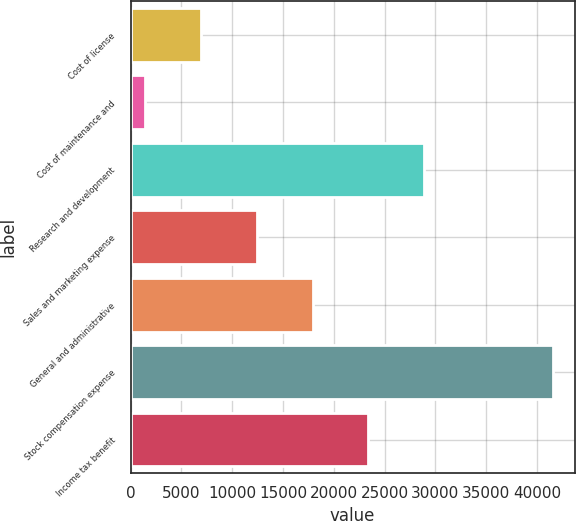<chart> <loc_0><loc_0><loc_500><loc_500><bar_chart><fcel>Cost of license<fcel>Cost of maintenance and<fcel>Research and development<fcel>Sales and marketing expense<fcel>General and administrative<fcel>Stock compensation expense<fcel>Income tax benefit<nl><fcel>6915.8<fcel>1416<fcel>28915<fcel>12415.6<fcel>17915.4<fcel>41616<fcel>23415.2<nl></chart> 